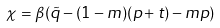<formula> <loc_0><loc_0><loc_500><loc_500>\chi = \beta ( \tilde { q } - ( 1 - m ) ( p + t ) - m p )</formula> 